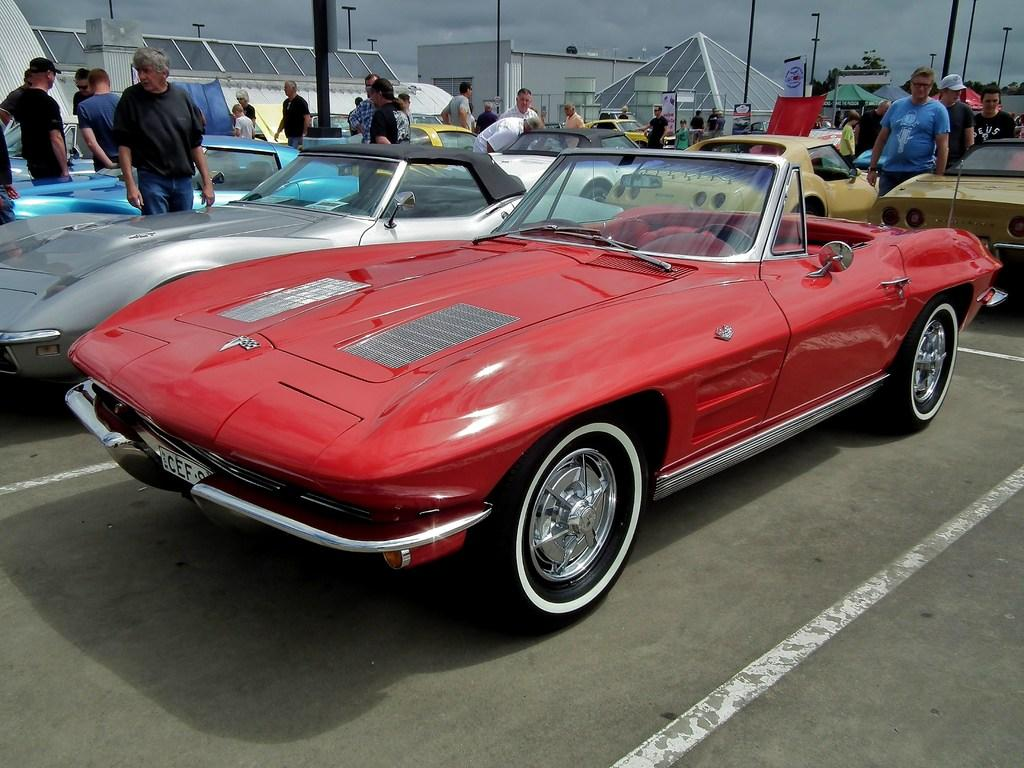What type of vehicles are parked in the parking slots? There are motor vehicles in the parking slots. What are the people standing on the floor doing? There are persons standing on the floor, but their actions are not specified in the facts. What structures can be seen in the image? Street poles, street lights, sheds, and buildings are visible in the image. What type of vegetation is present in the image? Trees are present in the image. What is visible in the sky? The sky is visible in the image, and clouds are present in it. What type of honey is being served to the people standing on the floor? There is no mention of honey or any food or drink being served in the image. What is the noise level in the image? The noise level is not mentioned in the facts provided, so it cannot be determined from the image. 